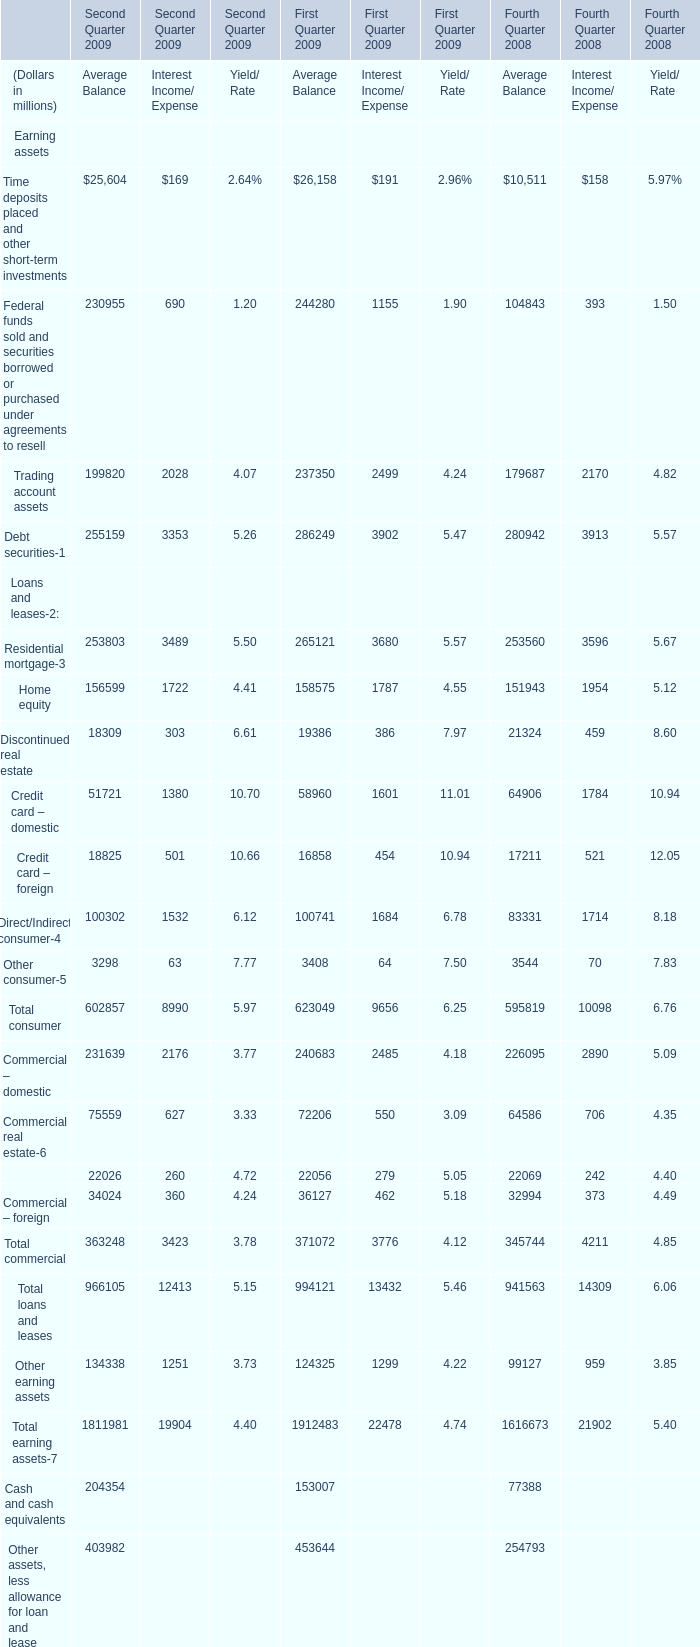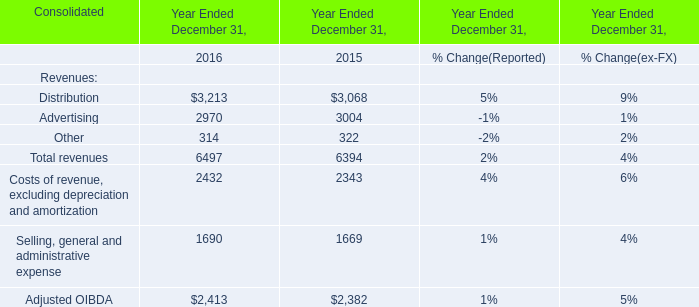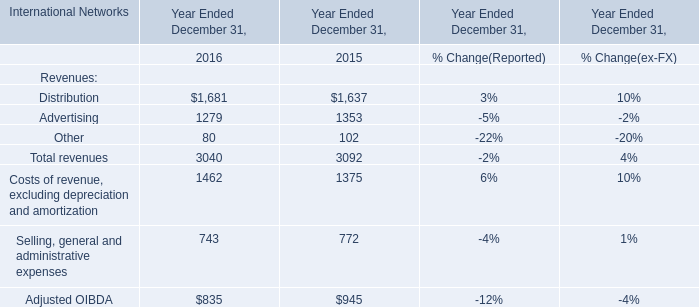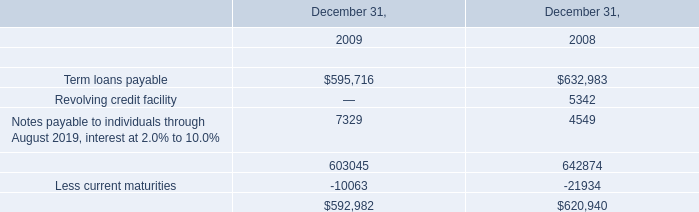What's the sum of Time deposits placed and other short-term investment in Second Quarter 2009? (in million) 
Computations: (25604 + 169)
Answer: 25773.0. 